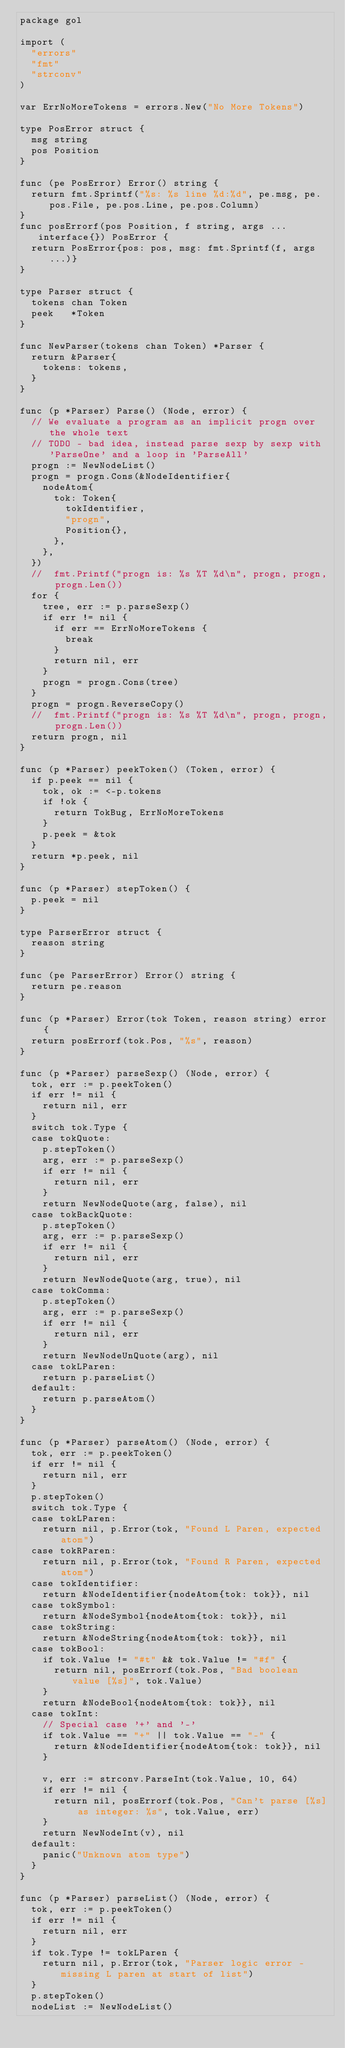Convert code to text. <code><loc_0><loc_0><loc_500><loc_500><_Go_>package gol

import (
	"errors"
	"fmt"
	"strconv"
)

var ErrNoMoreTokens = errors.New("No More Tokens")

type PosError struct {
	msg string
	pos Position
}

func (pe PosError) Error() string {
	return fmt.Sprintf("%s: %s line %d:%d", pe.msg, pe.pos.File, pe.pos.Line, pe.pos.Column)
}
func posErrorf(pos Position, f string, args ...interface{}) PosError {
	return PosError{pos: pos, msg: fmt.Sprintf(f, args...)}
}

type Parser struct {
	tokens chan Token
	peek   *Token
}

func NewParser(tokens chan Token) *Parser {
	return &Parser{
		tokens: tokens,
	}
}

func (p *Parser) Parse() (Node, error) {
	// We evaluate a program as an implicit progn over the whole text
	// TODO - bad idea, instead parse sexp by sexp with 'ParseOne' and a loop in 'ParseAll'
	progn := NewNodeList()
	progn = progn.Cons(&NodeIdentifier{
		nodeAtom{
			tok: Token{
				tokIdentifier,
				"progn",
				Position{},
			},
		},
	})
	//	fmt.Printf("progn is: %s %T %d\n", progn, progn, progn.Len())
	for {
		tree, err := p.parseSexp()
		if err != nil {
			if err == ErrNoMoreTokens {
				break
			}
			return nil, err
		}
		progn = progn.Cons(tree)
	}
	progn = progn.ReverseCopy()
	//	fmt.Printf("progn is: %s %T %d\n", progn, progn, progn.Len())
	return progn, nil
}

func (p *Parser) peekToken() (Token, error) {
	if p.peek == nil {
		tok, ok := <-p.tokens
		if !ok {
			return TokBug, ErrNoMoreTokens
		}
		p.peek = &tok
	}
	return *p.peek, nil
}

func (p *Parser) stepToken() {
	p.peek = nil
}

type ParserError struct {
	reason string
}

func (pe ParserError) Error() string {
	return pe.reason
}

func (p *Parser) Error(tok Token, reason string) error {
	return posErrorf(tok.Pos, "%s", reason)
}

func (p *Parser) parseSexp() (Node, error) {
	tok, err := p.peekToken()
	if err != nil {
		return nil, err
	}
	switch tok.Type {
	case tokQuote:
		p.stepToken()
		arg, err := p.parseSexp()
		if err != nil {
			return nil, err
		}
		return NewNodeQuote(arg, false), nil
	case tokBackQuote:
		p.stepToken()
		arg, err := p.parseSexp()
		if err != nil {
			return nil, err
		}
		return NewNodeQuote(arg, true), nil
	case tokComma:
		p.stepToken()
		arg, err := p.parseSexp()
		if err != nil {
			return nil, err
		}
		return NewNodeUnQuote(arg), nil
	case tokLParen:
		return p.parseList()
	default:
		return p.parseAtom()
	}
}

func (p *Parser) parseAtom() (Node, error) {
	tok, err := p.peekToken()
	if err != nil {
		return nil, err
	}
	p.stepToken()
	switch tok.Type {
	case tokLParen:
		return nil, p.Error(tok, "Found L Paren, expected atom")
	case tokRParen:
		return nil, p.Error(tok, "Found R Paren, expected atom")
	case tokIdentifier:
		return &NodeIdentifier{nodeAtom{tok: tok}}, nil
	case tokSymbol:
		return &NodeSymbol{nodeAtom{tok: tok}}, nil
	case tokString:
		return &NodeString{nodeAtom{tok: tok}}, nil
	case tokBool:
		if tok.Value != "#t" && tok.Value != "#f" {
			return nil, posErrorf(tok.Pos, "Bad boolean value [%s]", tok.Value)
		}
		return &NodeBool{nodeAtom{tok: tok}}, nil
	case tokInt:
		// Special case '+' and '-'
		if tok.Value == "+" || tok.Value == "-" {
			return &NodeIdentifier{nodeAtom{tok: tok}}, nil
		}

		v, err := strconv.ParseInt(tok.Value, 10, 64)
		if err != nil {
			return nil, posErrorf(tok.Pos, "Can't parse [%s] as integer: %s", tok.Value, err)
		}
		return NewNodeInt(v), nil
	default:
		panic("Unknown atom type")
	}
}

func (p *Parser) parseList() (Node, error) {
	tok, err := p.peekToken()
	if err != nil {
		return nil, err
	}
	if tok.Type != tokLParen {
		return nil, p.Error(tok, "Parser logic error - missing L paren at start of list")
	}
	p.stepToken()
	nodeList := NewNodeList()</code> 